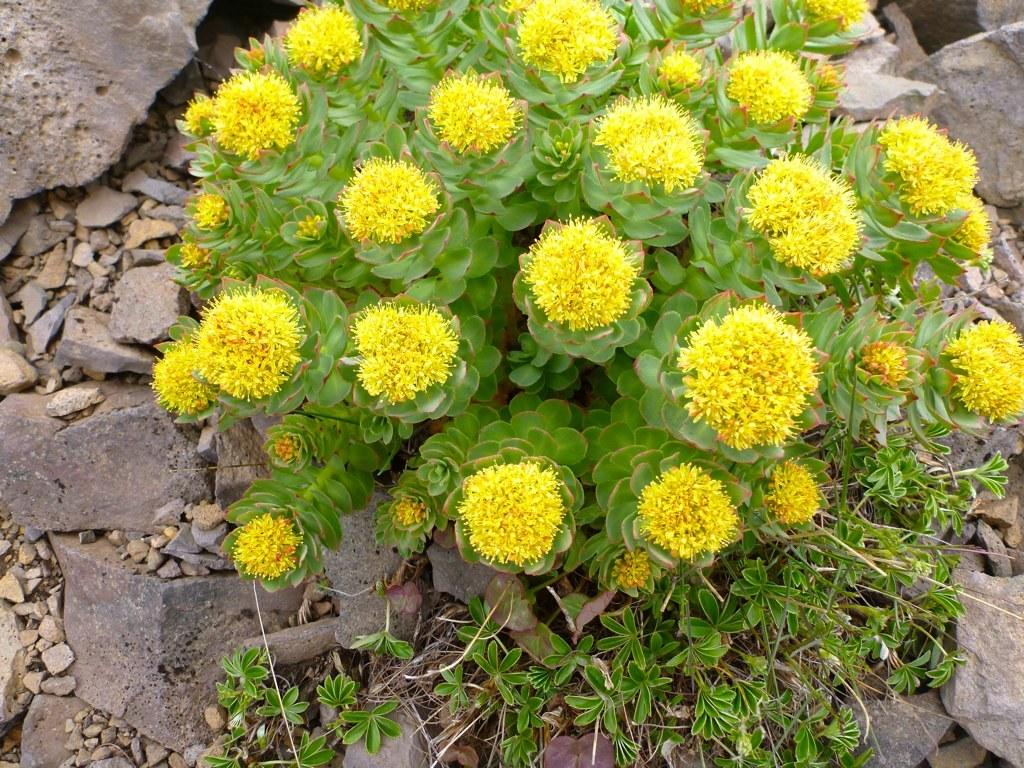What is the main subject in the center of the image? There is a plant in the center of the image. What type of flowers are on the plant? There are yellow flowers on the plant. What can be seen in the background of the image? There are stones and grass visible in the background of the image. What type of meat is being used as fuel in the image? There is no meat or fuel present in the image; it features a plant with yellow flowers and a background of stones and grass. 